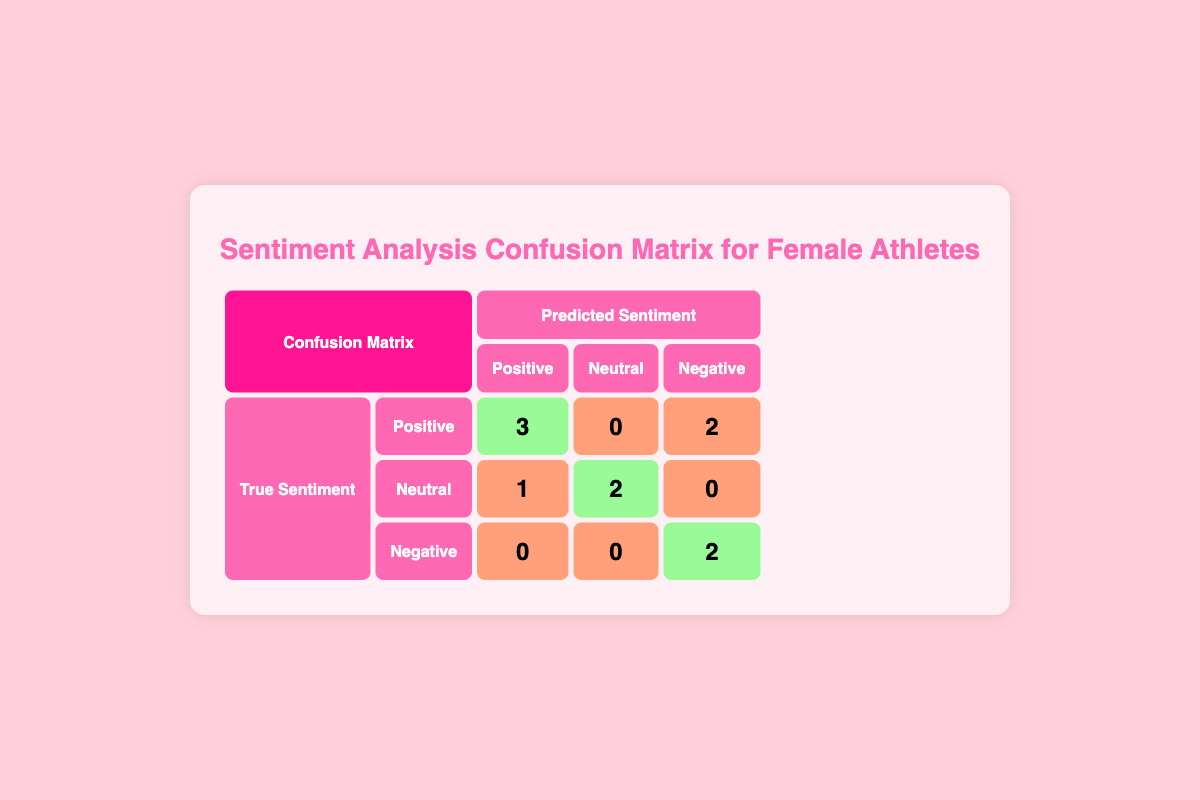What is the total number of correct predictions for positive sentiment? There are three athletes predicted with positive sentiment where the true sentiment is also positive: Serena Williams, Allyson Felix, and Sky Brown. Therefore, the total correct predictions for positive sentiment is 3.
Answer: 3 How many athletes were predicted to have a negative sentiment when their true sentiment was positive? There are two athletes with true positive sentiment but predicted negative sentiment: Megan Rapinoe and Katie Ledecky. Adding these up gives a total of 2.
Answer: 2 What is the number of neutral sentiments predicted accurately? There are two athletes who had true neutral sentiment and were also predicted as neutral: Simone Biles and Chloe Kim. Adding these gives a total of 2 accurately predicted neutral sentiments.
Answer: 2 Are there any athletes whose true sentiment was negative but predicted as positive? Looking at the data, there are no athletes who had a true negative sentiment that were predicted as positive, so the answer is no.
Answer: No What is the overall accuracy of the sentiment predictions? To find the accuracy, we identify the total correct predictions (3 positive + 2 neutral + 2 negative = 7) out of a total of 10 athletes. The accuracy can be calculated as 7/10, which simplifies to 70%.
Answer: 70% What is the ratio of correct predictions to incorrect predictions for negative sentiments? There are 2 correct predictions and 2 incorrect predictions for negative sentiments (0 predicted correctly for positive or neutral sentiments). Thus, the ratio of correct to incorrect predictions is 2:2, which simplifies to 1:1.
Answer: 1:1 How many athletes had their sentiments misclassified? The misclassified sentiments are all athletes minus the correctly predicted ones. There are 10 athletes total and 7 correct predictions (calculated previously), leading to 3 misclassified sentiments (10 - 7 = 3).
Answer: 3 What is the total number of negative sentiments predicted? Looking at the predictions in the table, there are 2 predicted negative sentiments (from Megan Rapinoe and Naomi Osaka). Hence, the total is 2.
Answer: 2 How many athletes had a true neutral sentiment that was incorrectly predicted? There are 1 athlete with true neutral sentiment predicted as positive (Carly Patterson), resulting in 1 incorrectly predicted neutral sentiment.
Answer: 1 